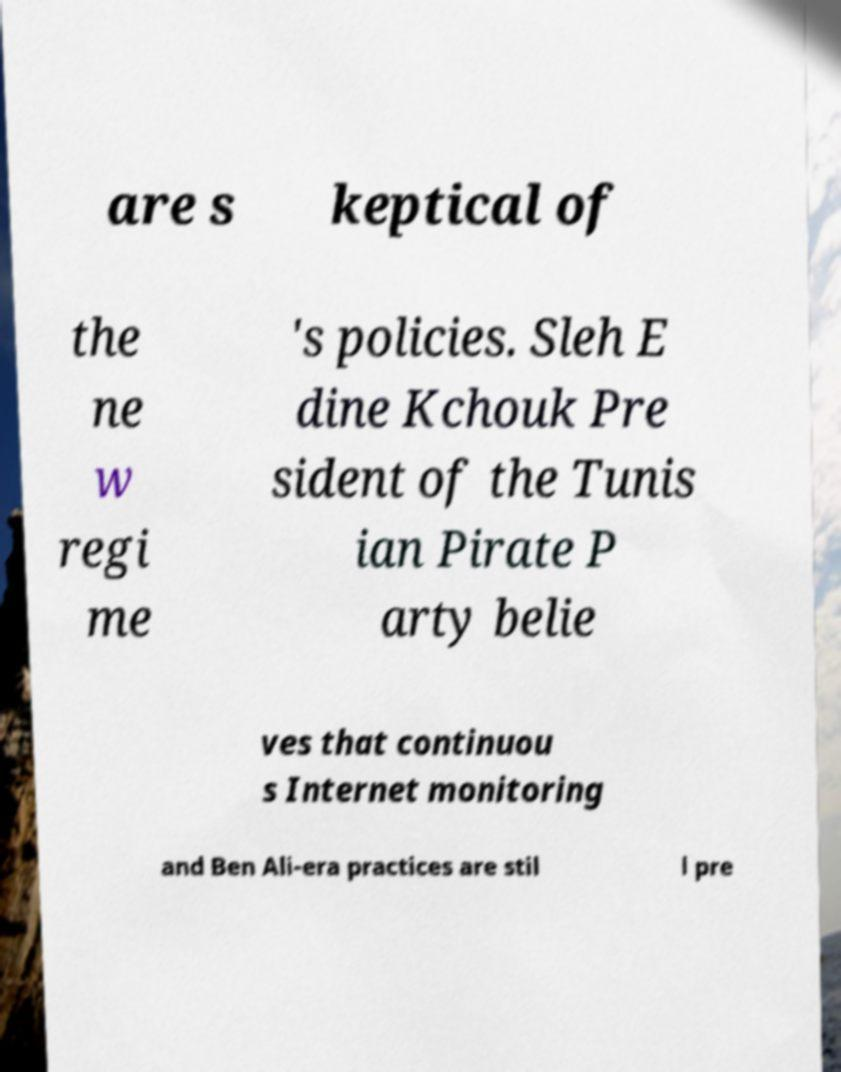For documentation purposes, I need the text within this image transcribed. Could you provide that? are s keptical of the ne w regi me 's policies. Sleh E dine Kchouk Pre sident of the Tunis ian Pirate P arty belie ves that continuou s Internet monitoring and Ben Ali-era practices are stil l pre 